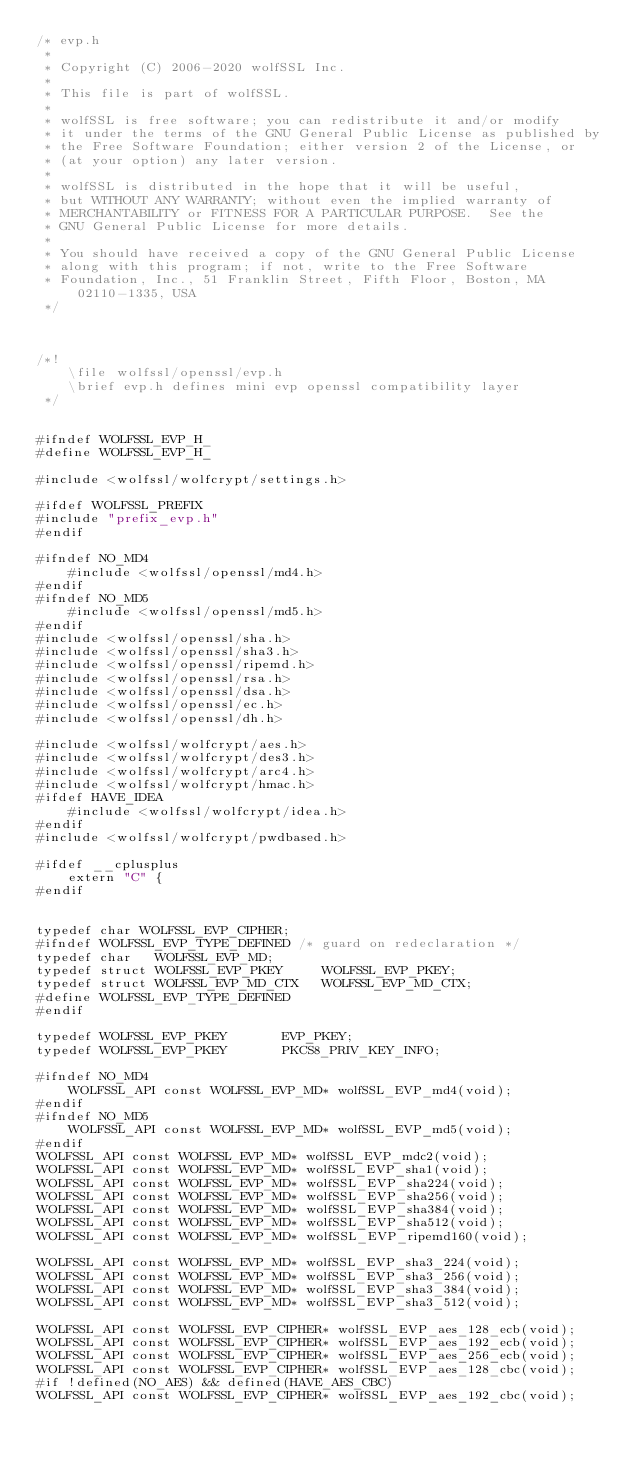<code> <loc_0><loc_0><loc_500><loc_500><_C_>/* evp.h
 *
 * Copyright (C) 2006-2020 wolfSSL Inc.
 *
 * This file is part of wolfSSL.
 *
 * wolfSSL is free software; you can redistribute it and/or modify
 * it under the terms of the GNU General Public License as published by
 * the Free Software Foundation; either version 2 of the License, or
 * (at your option) any later version.
 *
 * wolfSSL is distributed in the hope that it will be useful,
 * but WITHOUT ANY WARRANTY; without even the implied warranty of
 * MERCHANTABILITY or FITNESS FOR A PARTICULAR PURPOSE.  See the
 * GNU General Public License for more details.
 *
 * You should have received a copy of the GNU General Public License
 * along with this program; if not, write to the Free Software
 * Foundation, Inc., 51 Franklin Street, Fifth Floor, Boston, MA 02110-1335, USA
 */



/*!
    \file wolfssl/openssl/evp.h
    \brief evp.h defines mini evp openssl compatibility layer
 */


#ifndef WOLFSSL_EVP_H_
#define WOLFSSL_EVP_H_

#include <wolfssl/wolfcrypt/settings.h>

#ifdef WOLFSSL_PREFIX
#include "prefix_evp.h"
#endif

#ifndef NO_MD4
    #include <wolfssl/openssl/md4.h>
#endif
#ifndef NO_MD5
    #include <wolfssl/openssl/md5.h>
#endif
#include <wolfssl/openssl/sha.h>
#include <wolfssl/openssl/sha3.h>
#include <wolfssl/openssl/ripemd.h>
#include <wolfssl/openssl/rsa.h>
#include <wolfssl/openssl/dsa.h>
#include <wolfssl/openssl/ec.h>
#include <wolfssl/openssl/dh.h>

#include <wolfssl/wolfcrypt/aes.h>
#include <wolfssl/wolfcrypt/des3.h>
#include <wolfssl/wolfcrypt/arc4.h>
#include <wolfssl/wolfcrypt/hmac.h>
#ifdef HAVE_IDEA
    #include <wolfssl/wolfcrypt/idea.h>
#endif
#include <wolfssl/wolfcrypt/pwdbased.h>

#ifdef __cplusplus
    extern "C" {
#endif


typedef char WOLFSSL_EVP_CIPHER;
#ifndef WOLFSSL_EVP_TYPE_DEFINED /* guard on redeclaration */
typedef char   WOLFSSL_EVP_MD;
typedef struct WOLFSSL_EVP_PKEY     WOLFSSL_EVP_PKEY;
typedef struct WOLFSSL_EVP_MD_CTX   WOLFSSL_EVP_MD_CTX;
#define WOLFSSL_EVP_TYPE_DEFINED
#endif

typedef WOLFSSL_EVP_PKEY       EVP_PKEY;
typedef WOLFSSL_EVP_PKEY       PKCS8_PRIV_KEY_INFO;

#ifndef NO_MD4
    WOLFSSL_API const WOLFSSL_EVP_MD* wolfSSL_EVP_md4(void);
#endif
#ifndef NO_MD5
    WOLFSSL_API const WOLFSSL_EVP_MD* wolfSSL_EVP_md5(void);
#endif
WOLFSSL_API const WOLFSSL_EVP_MD* wolfSSL_EVP_mdc2(void);
WOLFSSL_API const WOLFSSL_EVP_MD* wolfSSL_EVP_sha1(void);
WOLFSSL_API const WOLFSSL_EVP_MD* wolfSSL_EVP_sha224(void);
WOLFSSL_API const WOLFSSL_EVP_MD* wolfSSL_EVP_sha256(void);
WOLFSSL_API const WOLFSSL_EVP_MD* wolfSSL_EVP_sha384(void);
WOLFSSL_API const WOLFSSL_EVP_MD* wolfSSL_EVP_sha512(void);
WOLFSSL_API const WOLFSSL_EVP_MD* wolfSSL_EVP_ripemd160(void);

WOLFSSL_API const WOLFSSL_EVP_MD* wolfSSL_EVP_sha3_224(void);
WOLFSSL_API const WOLFSSL_EVP_MD* wolfSSL_EVP_sha3_256(void);
WOLFSSL_API const WOLFSSL_EVP_MD* wolfSSL_EVP_sha3_384(void);
WOLFSSL_API const WOLFSSL_EVP_MD* wolfSSL_EVP_sha3_512(void);

WOLFSSL_API const WOLFSSL_EVP_CIPHER* wolfSSL_EVP_aes_128_ecb(void);
WOLFSSL_API const WOLFSSL_EVP_CIPHER* wolfSSL_EVP_aes_192_ecb(void);
WOLFSSL_API const WOLFSSL_EVP_CIPHER* wolfSSL_EVP_aes_256_ecb(void);
WOLFSSL_API const WOLFSSL_EVP_CIPHER* wolfSSL_EVP_aes_128_cbc(void);
#if !defined(NO_AES) && defined(HAVE_AES_CBC)
WOLFSSL_API const WOLFSSL_EVP_CIPHER* wolfSSL_EVP_aes_192_cbc(void);</code> 